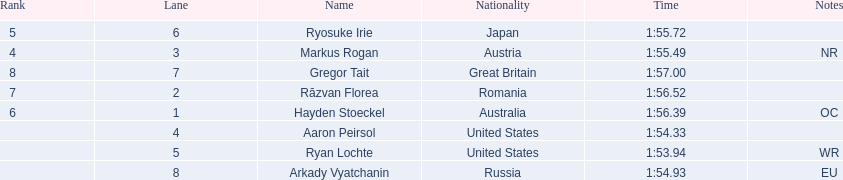Who are the swimmers? Ryan Lochte, Aaron Peirsol, Arkady Vyatchanin, Markus Rogan, Ryosuke Irie, Hayden Stoeckel, Răzvan Florea, Gregor Tait. What is ryosuke irie's time? 1:55.72. 